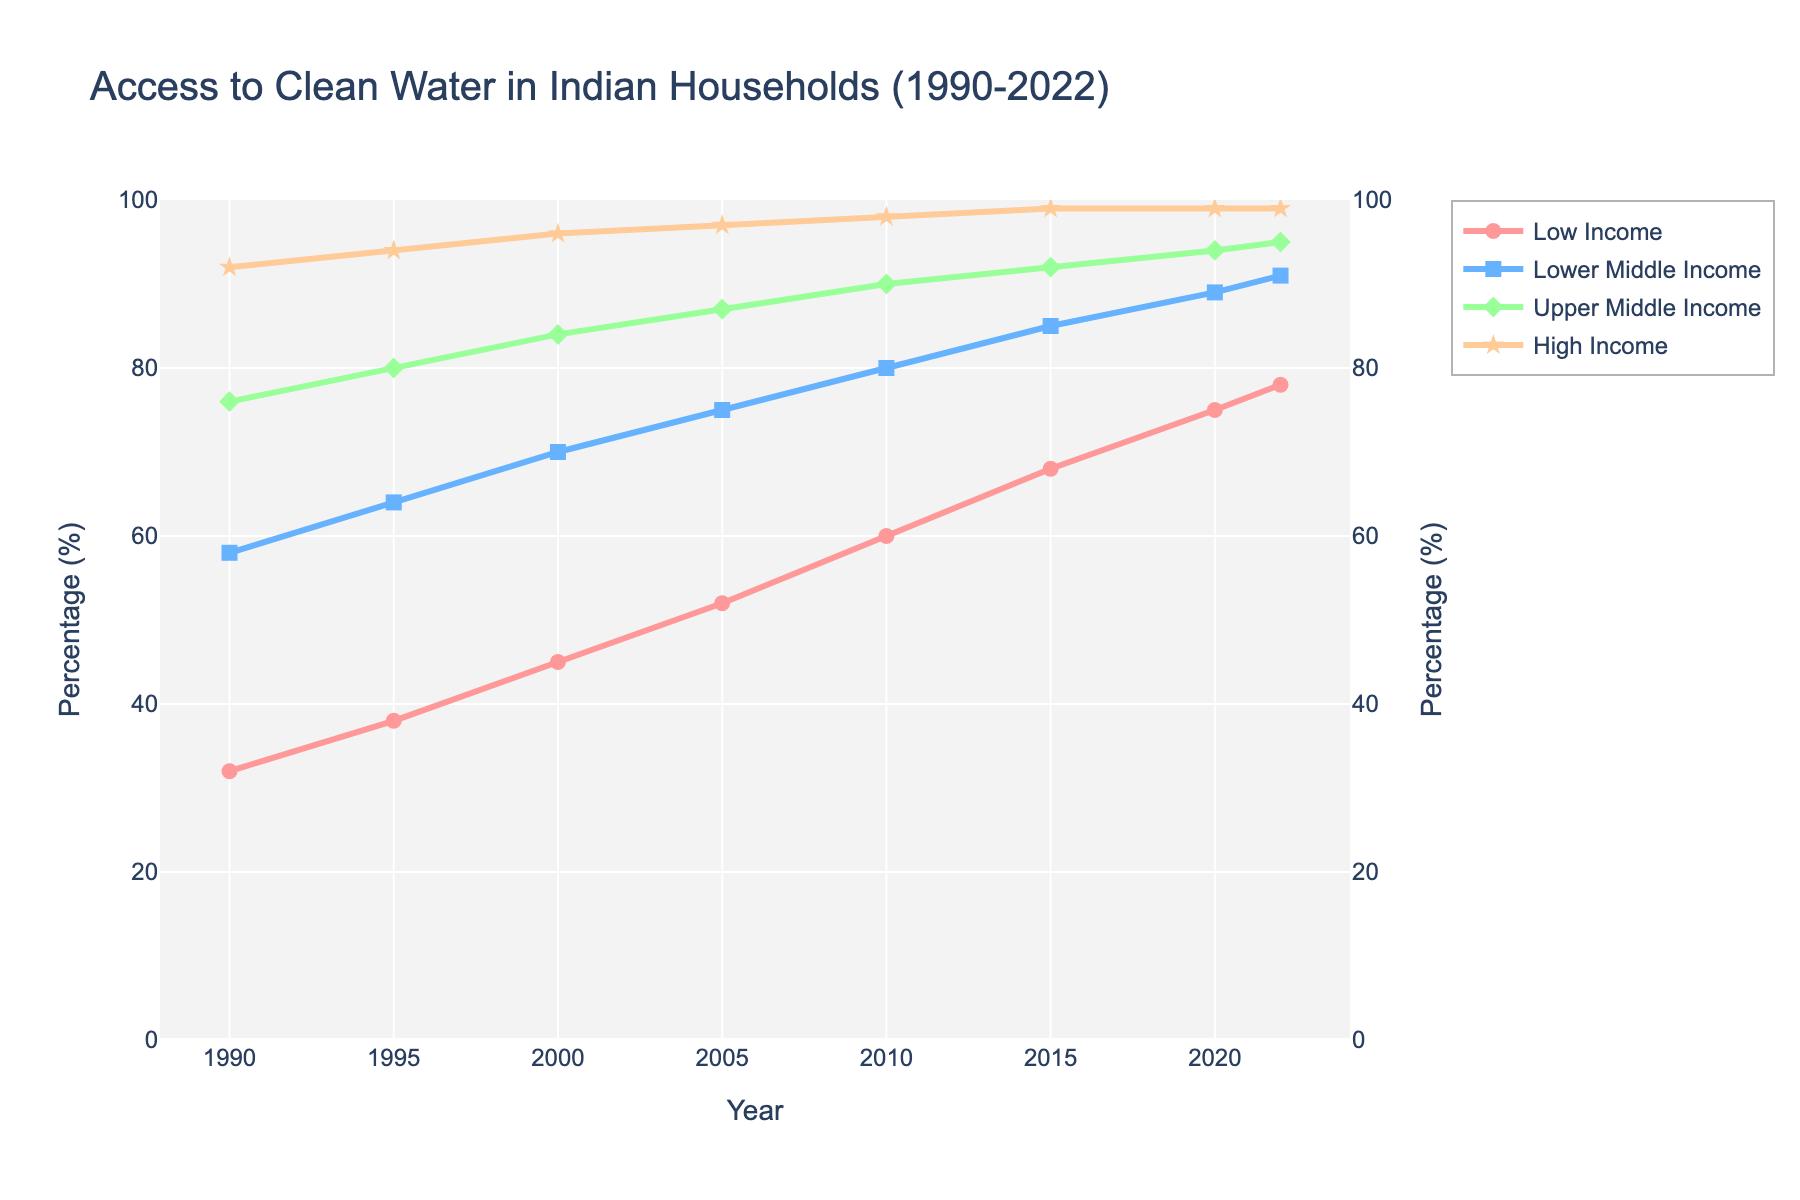What's the difference in access to clean water between Low Income and High Income households in 2022? The access for Low Income is 78% and for High Income is 99%. The difference is 99% - 78% = 21%.
Answer: 21% Which income group had the fastest increase in clean water access from 1990 to 2022? Calculate the increase for each group: Low Income (78% - 32% = 46%), Lower Middle Income (91% - 58% = 33%), Upper Middle Income (95% - 76% = 19%), High Income (99% - 92% = 7%). Low Income had the largest increase.
Answer: Low Income In which year did Lower Middle Income households reach 80% access to clean water? By checking the data points, Lower Middle Income households reached 80% in 2010.
Answer: 2010 Compare the percentage of clean water access between Lower Middle Income and Upper Middle Income households in 2020. In 2020, Lower Middle Income had 89% and Upper Middle Income had 94%. Upper Middle Income had a higher percentage.
Answer: Upper Middle Income What is the average percentage of clean water access for High Income households over all the years? Sum the percentages for High Income: 92 + 94 + 96 + 97 + 98 + 99 + 99 + 99 = 774. There are 8 data points. The average is 774 / 8 = 96.75%.
Answer: 96.75% Which income group shows the most improvement from 2000 to 2010? Calculate improvements for each group: Low Income (60% - 45% = 15%), Lower Middle Income (80% - 70% = 10%), Upper Middle Income (90% - 84% = 6%), High Income (98% - 96% = 2%). Low Income had the most improvement.
Answer: Low Income What is the median percentage of clean water access for Lower Middle Income households for the given years? Order percentages for Lower Middle Income: 58, 64, 70, 75, 80, 85, 89, 91. Middle values are 75 and 80. Median is (75 + 80) / 2 = 77.5%.
Answer: 77.5% What color line represents Upper Middle Income households? The Upper Middle Income households are represented by a green line.
Answer: Green 